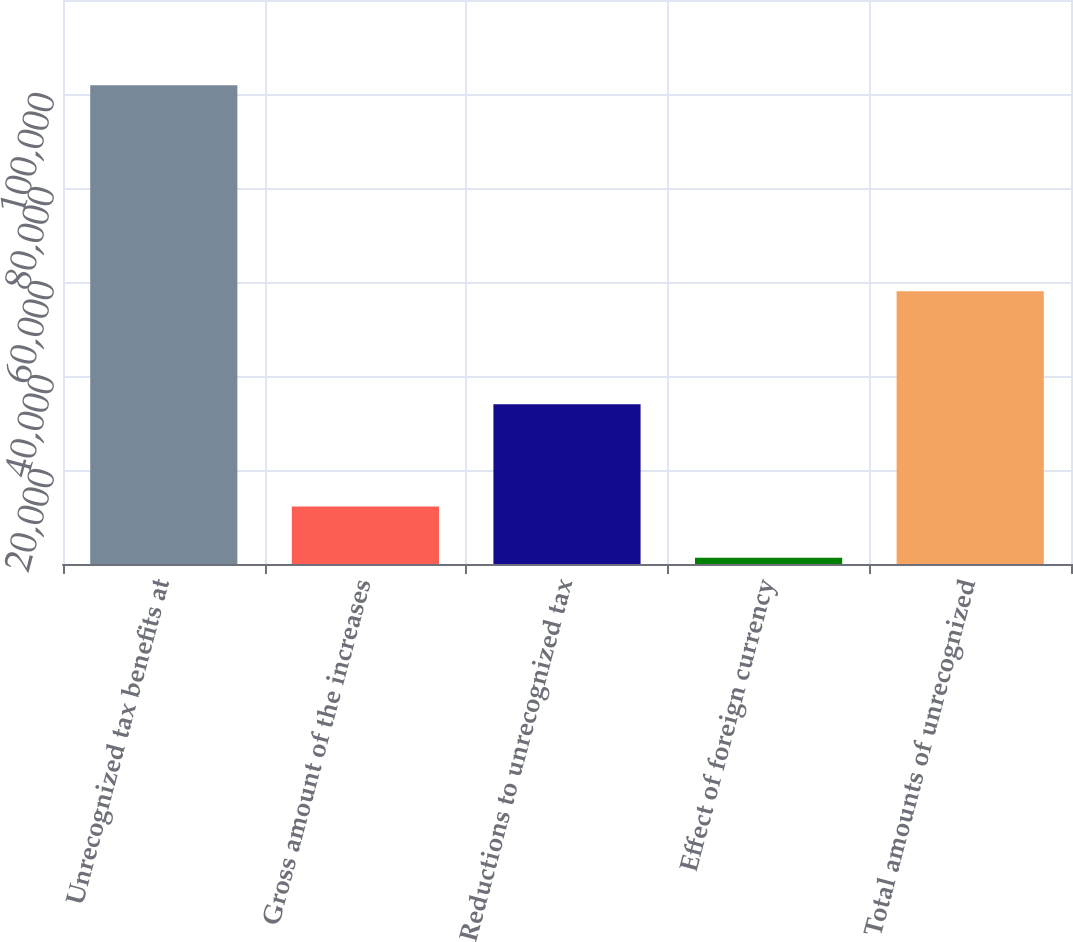Convert chart to OTSL. <chart><loc_0><loc_0><loc_500><loc_500><bar_chart><fcel>Unrecognized tax benefits at<fcel>Gross amount of the increases<fcel>Reductions to unrecognized tax<fcel>Effect of foreign currency<fcel>Total amounts of unrecognized<nl><fcel>101857<fcel>12214.9<fcel>33984.7<fcel>1330<fcel>58022<nl></chart> 